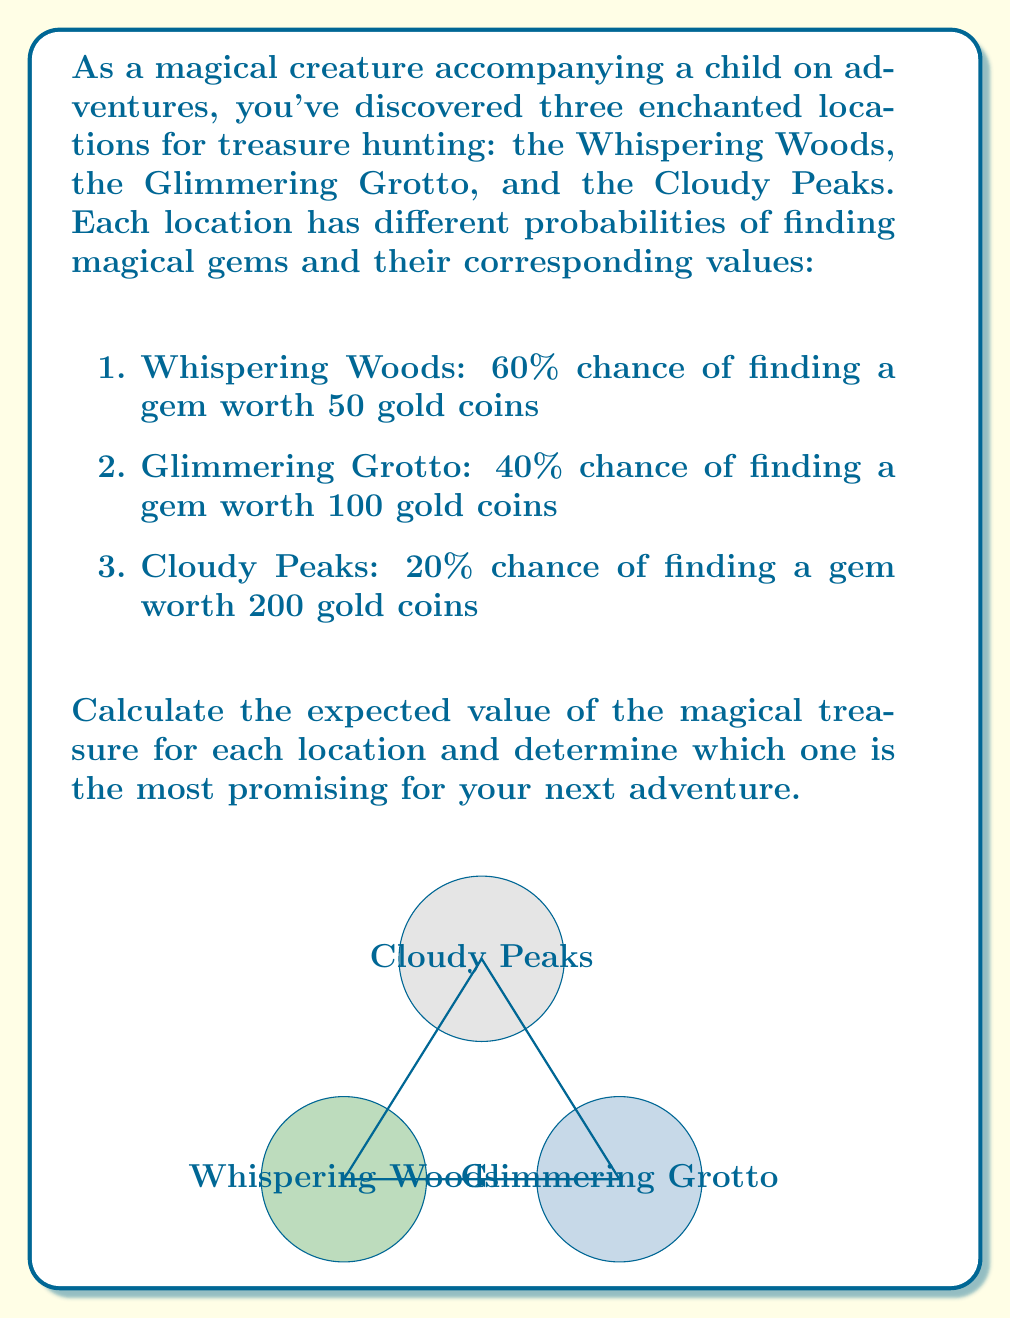Provide a solution to this math problem. To solve this problem, we need to calculate the expected value for each location using the formula:

$$ E(X) = p \times v $$

Where $E(X)$ is the expected value, $p$ is the probability of finding a gem, and $v$ is the value of the gem.

1. Whispering Woods:
   $$ E(X_W) = 0.60 \times 50 = 30 \text{ gold coins} $$

2. Glimmering Grotto:
   $$ E(X_G) = 0.40 \times 100 = 40 \text{ gold coins} $$

3. Cloudy Peaks:
   $$ E(X_C) = 0.20 \times 200 = 40 \text{ gold coins} $$

Comparing the expected values:
- Whispering Woods: 30 gold coins
- Glimmering Grotto: 40 gold coins
- Cloudy Peaks: 40 gold coins

The Glimmering Grotto and Cloudy Peaks have the highest expected value of 40 gold coins each, making them equally promising for the next adventure.
Answer: Glimmering Grotto and Cloudy Peaks, both with an expected value of 40 gold coins. 